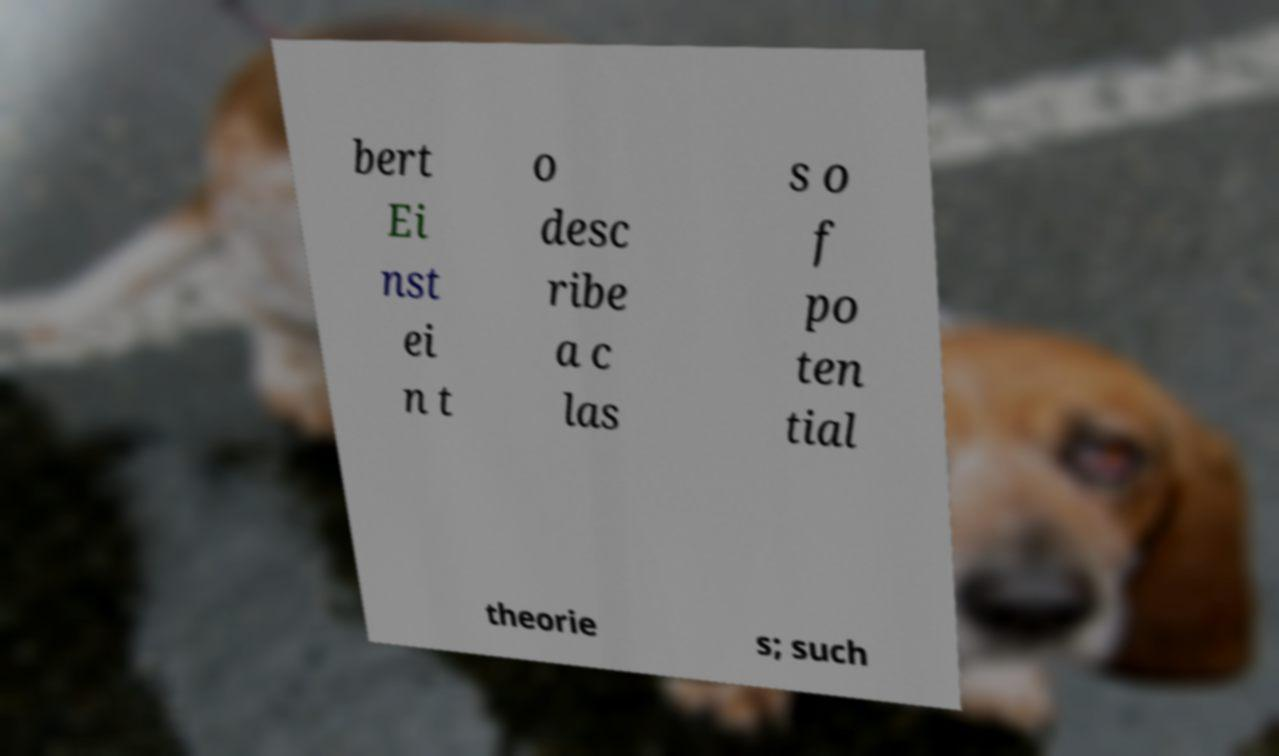What messages or text are displayed in this image? I need them in a readable, typed format. bert Ei nst ei n t o desc ribe a c las s o f po ten tial theorie s; such 